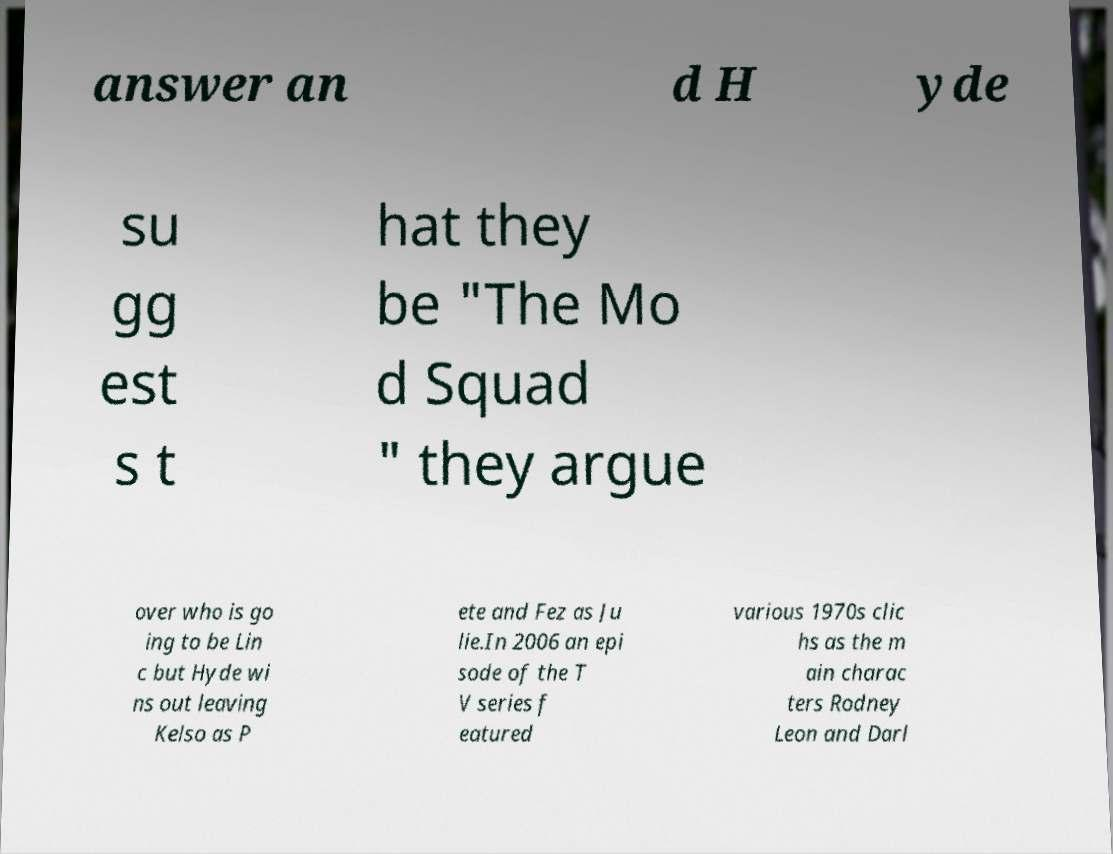Please identify and transcribe the text found in this image. answer an d H yde su gg est s t hat they be "The Mo d Squad " they argue over who is go ing to be Lin c but Hyde wi ns out leaving Kelso as P ete and Fez as Ju lie.In 2006 an epi sode of the T V series f eatured various 1970s clic hs as the m ain charac ters Rodney Leon and Darl 